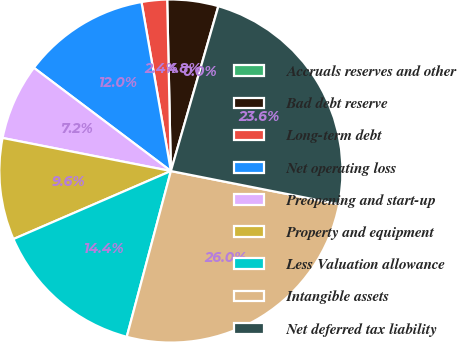Convert chart to OTSL. <chart><loc_0><loc_0><loc_500><loc_500><pie_chart><fcel>Accruals reserves and other<fcel>Bad debt reserve<fcel>Long-term debt<fcel>Net operating loss<fcel>Preopening and start-up<fcel>Property and equipment<fcel>Less Valuation allowance<fcel>Intangible assets<fcel>Net deferred tax liability<nl><fcel>0.01%<fcel>4.8%<fcel>2.4%<fcel>11.98%<fcel>7.19%<fcel>9.58%<fcel>14.37%<fcel>26.04%<fcel>23.64%<nl></chart> 